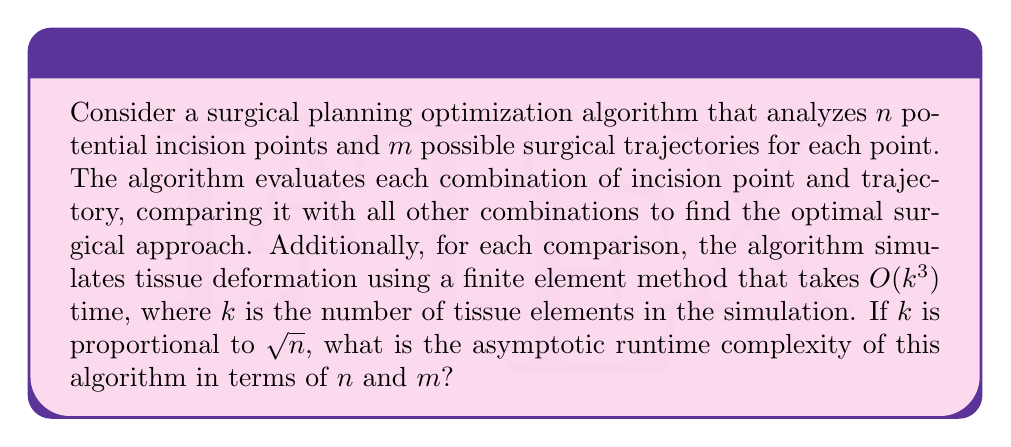Give your solution to this math problem. Let's break down the problem and analyze it step by step:

1. The algorithm considers $n$ incision points.

2. For each incision point, there are $m$ possible trajectories.

3. This means there are $n \cdot m$ total combinations of incision points and trajectories.

4. The algorithm compares each combination with all other combinations. This results in:
   $$(n \cdot m) \cdot (n \cdot m - 1) \approx (nm)^2$$ comparisons

5. For each comparison, a tissue deformation simulation is performed using a finite element method.

6. The simulation takes $O(k^3)$ time, where $k$ is the number of tissue elements.

7. We are given that $k$ is proportional to $\sqrt{n}$, so we can replace $k$ with $c\sqrt{n}$ where $c$ is some constant.

8. The time for each simulation is thus:
   $$O((c\sqrt{n})^3) = O(c^3n^{3/2}) = O(n^{3/2})$$

9. Combining steps 4 and 8, the total runtime is:
   $$(nm)^2 \cdot O(n^{3/2}) = O(n^{7/2}m^2)$$

Therefore, the asymptotic runtime complexity of the algorithm is $O(n^{7/2}m^2)$.
Answer: $O(n^{7/2}m^2)$ 